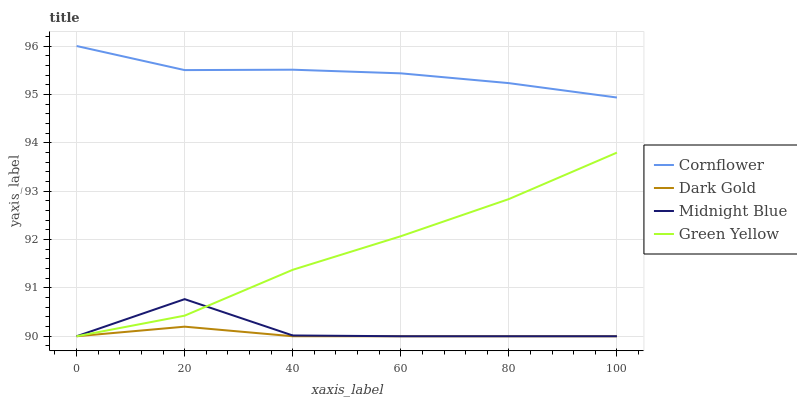Does Dark Gold have the minimum area under the curve?
Answer yes or no. Yes. Does Cornflower have the maximum area under the curve?
Answer yes or no. Yes. Does Green Yellow have the minimum area under the curve?
Answer yes or no. No. Does Green Yellow have the maximum area under the curve?
Answer yes or no. No. Is Dark Gold the smoothest?
Answer yes or no. Yes. Is Midnight Blue the roughest?
Answer yes or no. Yes. Is Green Yellow the smoothest?
Answer yes or no. No. Is Green Yellow the roughest?
Answer yes or no. No. Does Green Yellow have the lowest value?
Answer yes or no. Yes. Does Cornflower have the highest value?
Answer yes or no. Yes. Does Green Yellow have the highest value?
Answer yes or no. No. Is Green Yellow less than Cornflower?
Answer yes or no. Yes. Is Cornflower greater than Green Yellow?
Answer yes or no. Yes. Does Green Yellow intersect Dark Gold?
Answer yes or no. Yes. Is Green Yellow less than Dark Gold?
Answer yes or no. No. Is Green Yellow greater than Dark Gold?
Answer yes or no. No. Does Green Yellow intersect Cornflower?
Answer yes or no. No. 